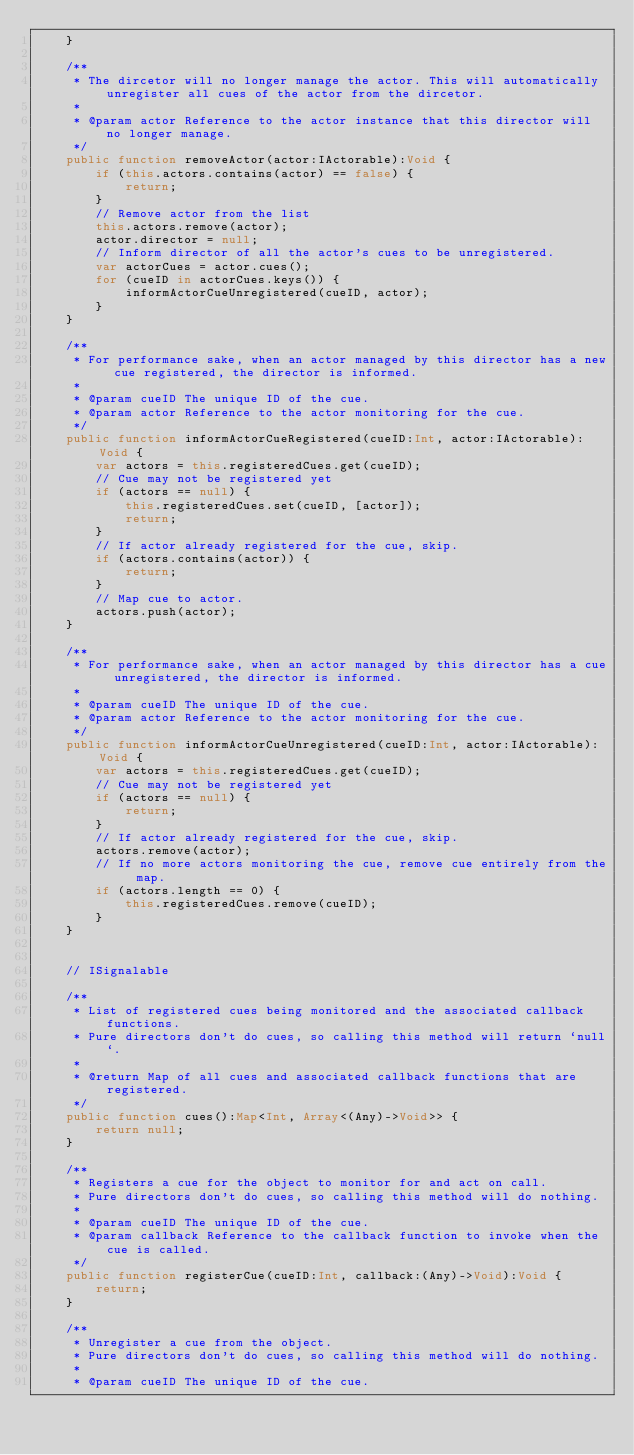<code> <loc_0><loc_0><loc_500><loc_500><_Haxe_>    }

    /**
     * The dircetor will no longer manage the actor. This will automatically unregister all cues of the actor from the dircetor.
     * 
     * @param actor Reference to the actor instance that this director will no longer manage.
     */
    public function removeActor(actor:IActorable):Void {
        if (this.actors.contains(actor) == false) {
            return;
        }
        // Remove actor from the list
        this.actors.remove(actor);
        actor.director = null;
        // Inform director of all the actor's cues to be unregistered.
        var actorCues = actor.cues();
        for (cueID in actorCues.keys()) {
            informActorCueUnregistered(cueID, actor);
        }
    }
 
    /**
     * For performance sake, when an actor managed by this director has a new cue registered, the director is informed.
     * 
     * @param cueID The unique ID of the cue.
     * @param actor Reference to the actor monitoring for the cue.
     */
    public function informActorCueRegistered(cueID:Int, actor:IActorable):Void {
        var actors = this.registeredCues.get(cueID);
        // Cue may not be registered yet
        if (actors == null) {
            this.registeredCues.set(cueID, [actor]);
            return;
        }
        // If actor already registered for the cue, skip.
        if (actors.contains(actor)) {
            return;
        }
        // Map cue to actor.
        actors.push(actor);
    }
 
    /**
     * For performance sake, when an actor managed by this director has a cue unregistered, the director is informed.
     * 
     * @param cueID The unique ID of the cue.
     * @param actor Reference to the actor monitoring for the cue.
     */
    public function informActorCueUnregistered(cueID:Int, actor:IActorable):Void {
        var actors = this.registeredCues.get(cueID);
        // Cue may not be registered yet
        if (actors == null) {
            return;
        }
        // If actor already registered for the cue, skip.
        actors.remove(actor);
        // If no more actors monitoring the cue, remove cue entirely from the map.
        if (actors.length == 0) {
            this.registeredCues.remove(cueID);
        }
    }


    // ISignalable

    /**
	 * List of registered cues being monitored and the associated callback functions.
     * Pure directors don't do cues, so calling this method will return `null`.
	 * 
	 * @return Map of all cues and associated callback functions that are registered.
	 */
	public function cues():Map<Int, Array<(Any)->Void>> {
        return null;
    }

	/**
	 * Registers a cue for the object to monitor for and act on call.
     * Pure directors don't do cues, so calling this method will do nothing.
	 * 
	 * @param cueID The unique ID of the cue.
	 * @param callback Reference to the callback function to invoke when the cue is called.
	 */
	public function registerCue(cueID:Int, callback:(Any)->Void):Void {
        return;
    }

	/**
	 * Unregister a cue from the object.
     * Pure directors don't do cues, so calling this method will do nothing.
	 * 
	 * @param cueID The unique ID of the cue.</code> 